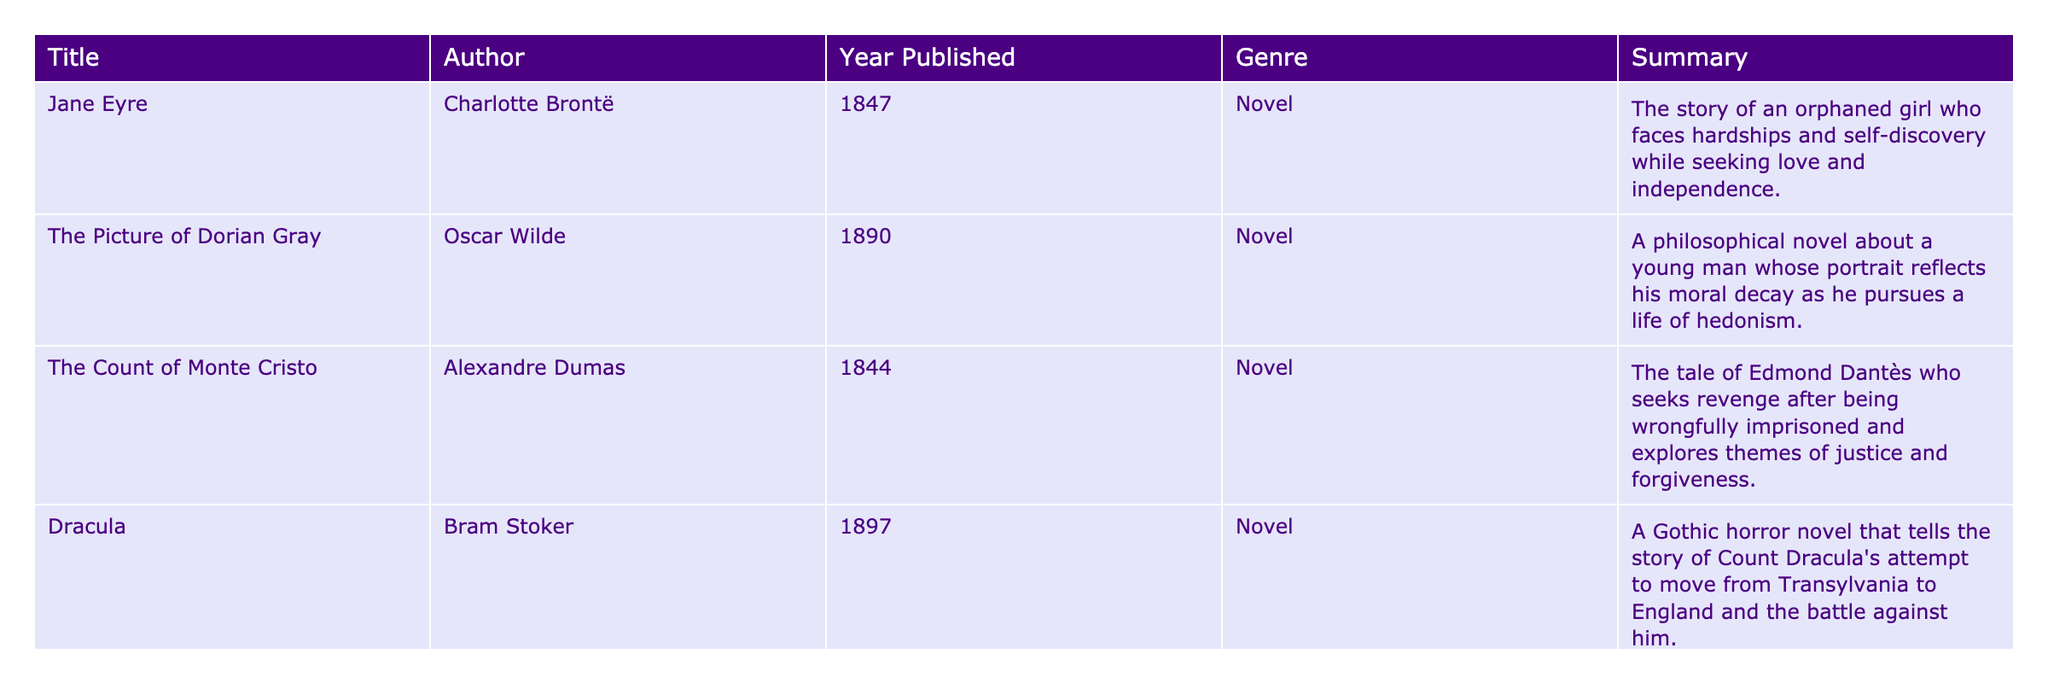What is the title of the novel by Charlotte Brontë? The table lists several classic literature works and their authors. Referring to the entry with Charlotte Brontë as the author, the title of her novel is "Jane Eyre."
Answer: "Jane Eyre" Which year was "The Picture of Dorian Gray" published? Looking at the table, the row corresponding to "The Picture of Dorian Gray" shows that it was published in 1890.
Answer: 1890 Who is the author of "Anna Karenina"? By examining the entry for "Anna Karenina," the author listed is Leo Tolstoy.
Answer: Leo Tolstoy How many novels listed were published in the 1800s? Analyzing the publication years, "Jane Eyre," "The Count of Monte Cristo," "Anna Karenina," and "Dracula" were published in the 1800s. That's a total of four novels.
Answer: 4 Is "Dracula" a novel in the genre of Gothic horror? The genre for "Dracula" is specified as Gothic horror in the table. Thus, the statement is true.
Answer: Yes Which novel features revenge as a central theme? Examining the summaries, "The Count of Monte Cristo" explicitly discusses Edmond Dantès seeking revenge after being wrongfully imprisoned.
Answer: "The Count of Monte Cristo" What is the difference in publication years between "Jane Eyre" and "The Count of Monte Cristo"? "Jane Eyre" was published in 1847 and "The Count of Monte Cristo" in 1844. The difference is calculated by subtracting 1844 from 1847, resulting in a difference of 3 years.
Answer: 3 years Which author has two works listed in the table? Reviewing the authors, only Alexandre Dumas with "The Count of Monte Cristo" has a single work in the table, while there is no author with two works listed. Therefore, the answer is no.
Answer: No What is the average publication year of the novels in the table? The publication years are 1847, 1890, 1844, 1897, and 1877. Adding these gives a total of 9345. Dividing by the number of novels (5) provides an average year of 1869.
Answer: 1869 How many of the novels have a summary that mentions love? Looking through the summaries, "Jane Eyre" mentions seeking love, and "Anna Karenina" focuses on a love story. Thus, two novels have love mentioned in their summaries.
Answer: 2 